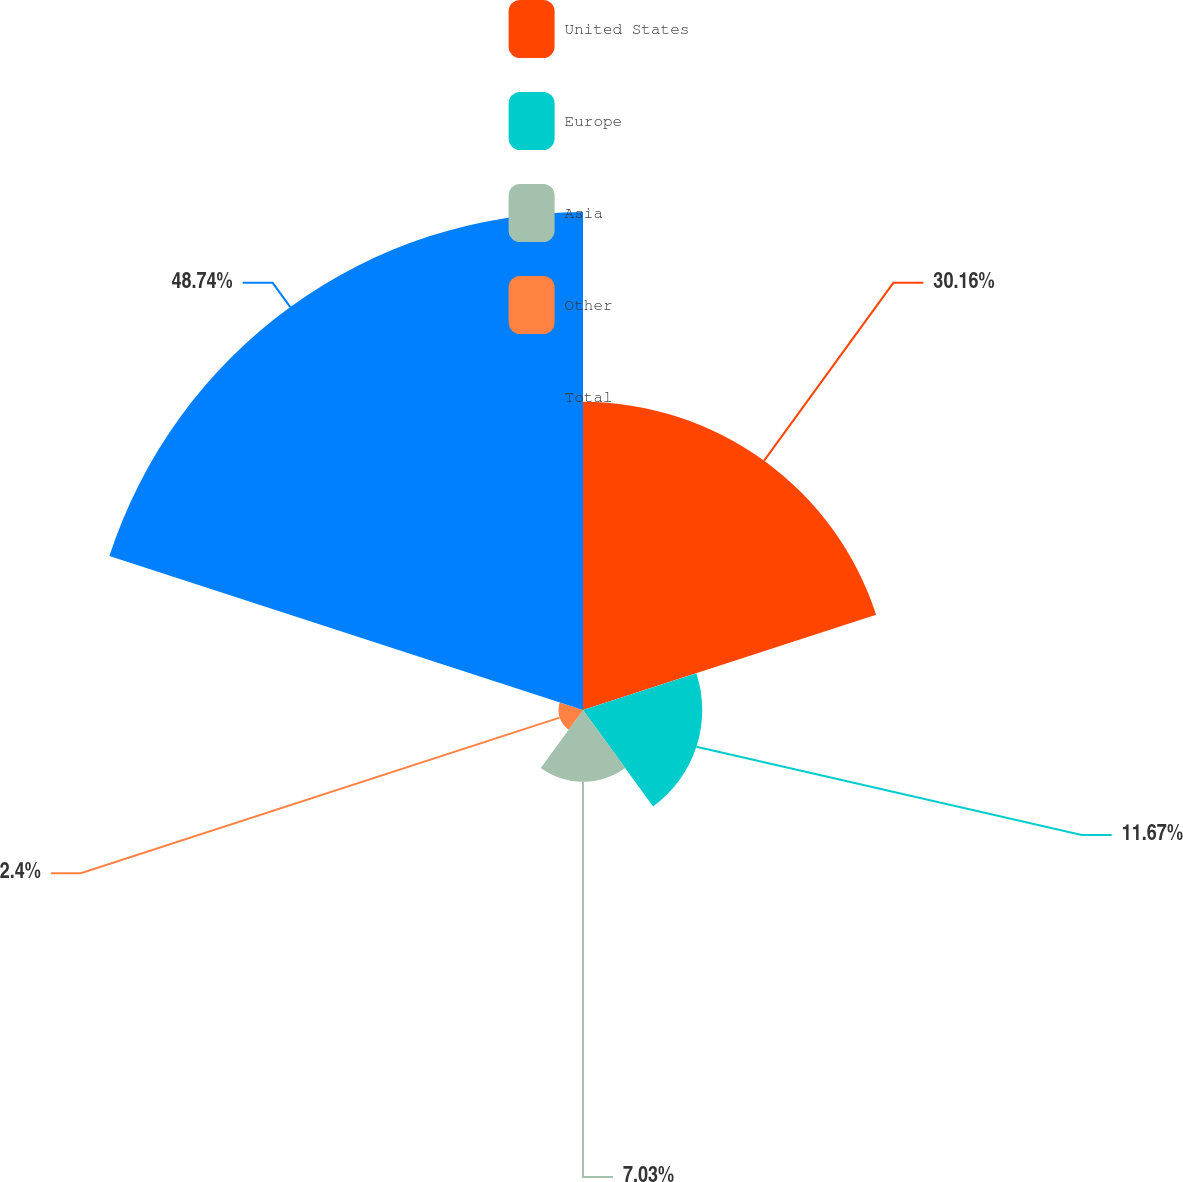<chart> <loc_0><loc_0><loc_500><loc_500><pie_chart><fcel>United States<fcel>Europe<fcel>Asia<fcel>Other<fcel>Total<nl><fcel>30.16%<fcel>11.67%<fcel>7.03%<fcel>2.4%<fcel>48.74%<nl></chart> 